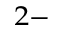<formula> <loc_0><loc_0><loc_500><loc_500>^ { 2 - }</formula> 